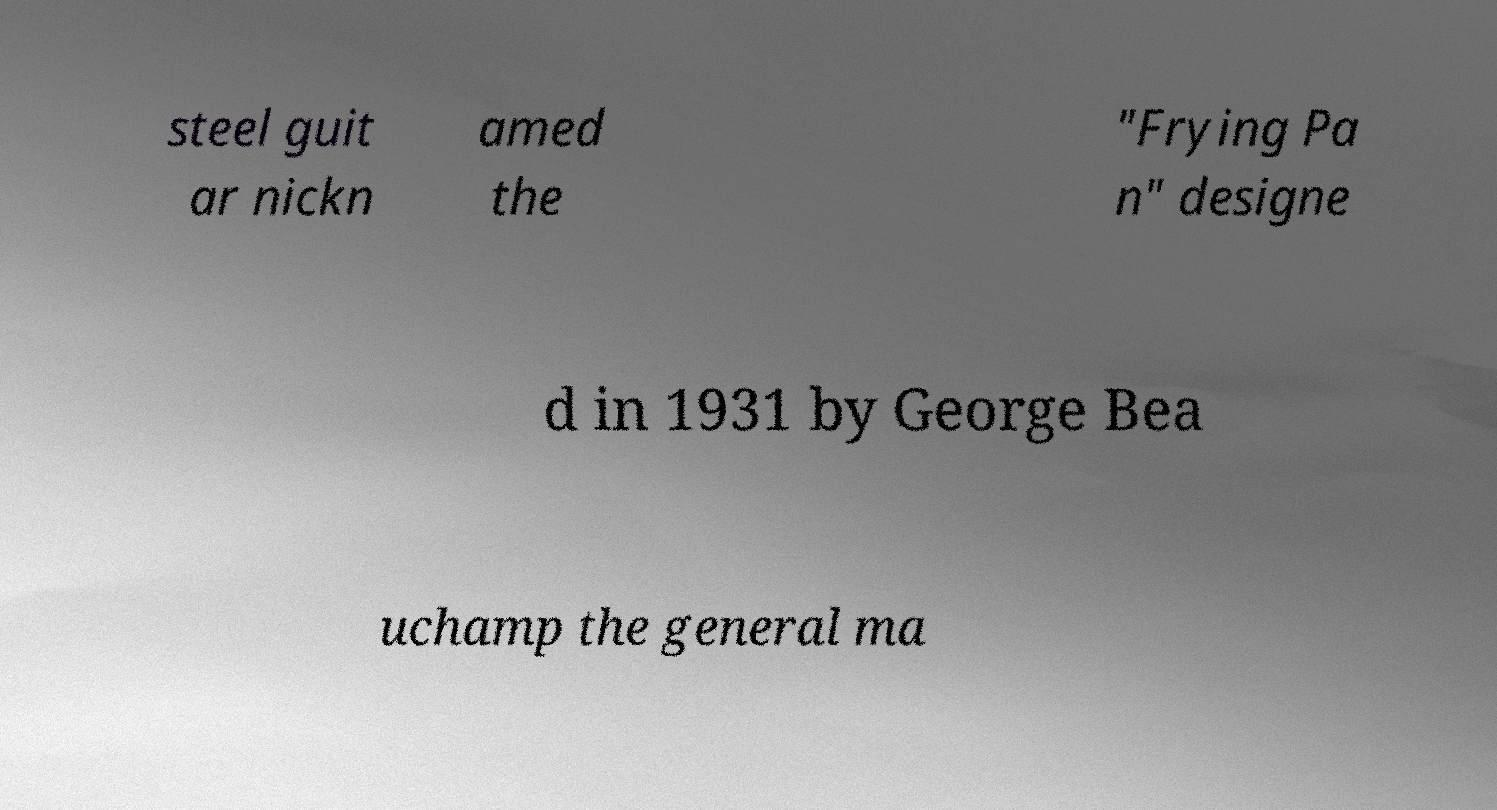I need the written content from this picture converted into text. Can you do that? steel guit ar nickn amed the "Frying Pa n" designe d in 1931 by George Bea uchamp the general ma 